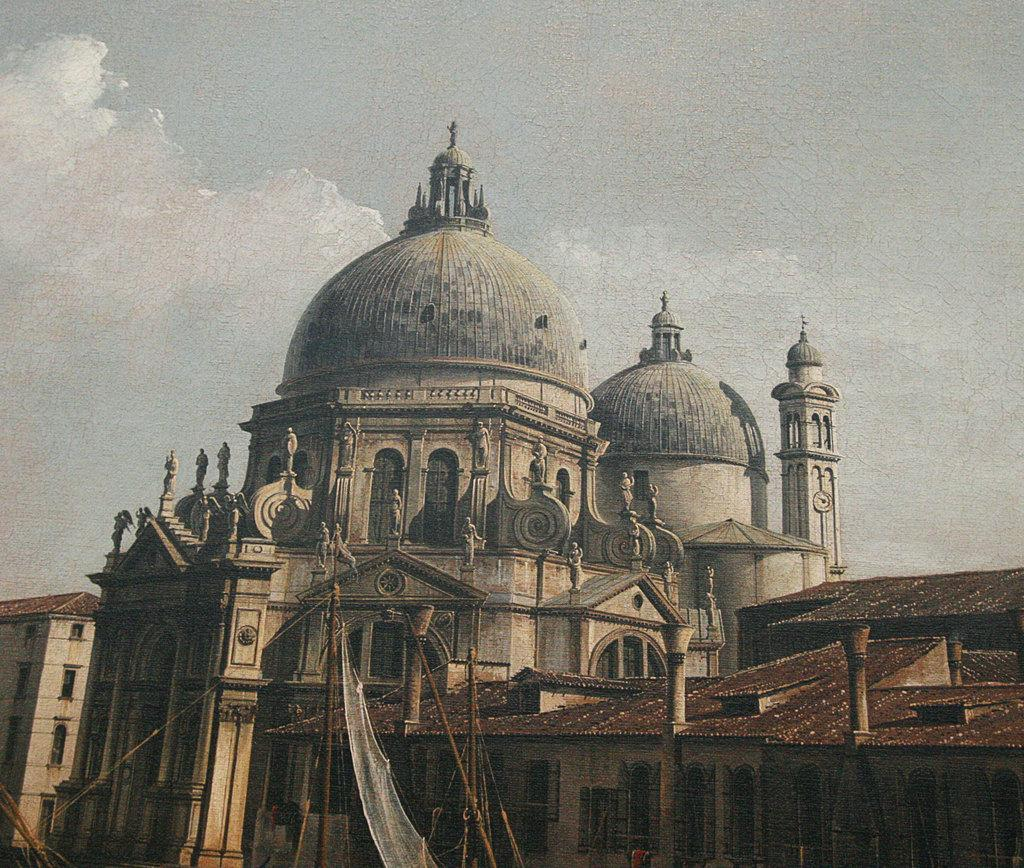What type of structures can be seen in the image? There are buildings in the image. What can be observed in the sky in the image? There are clouds visible in the image. What type of cable is being offered to the buildings in the image? There is no cable or offer present in the image; it only features buildings and clouds. What type of education is being provided to the buildings in the image? Buildings do not require education, as they are inanimate structures. 